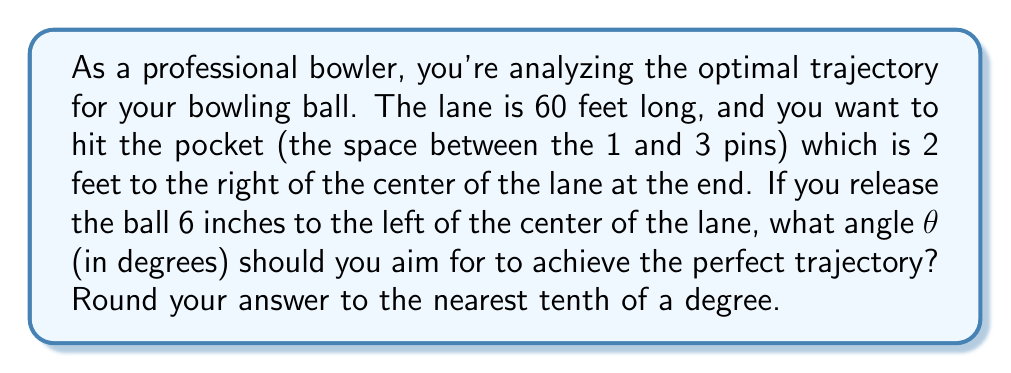Can you answer this question? Let's approach this step-by-step using trigonometry:

1) First, we need to visualize the problem. We have a right triangle where:
   - The length of the lane is the adjacent side (60 feet)
   - The horizontal distance the ball needs to travel is the opposite side

2) To find the opposite side, we need to add:
   - The distance from the pocket to the center (2 feet)
   - The distance from the release point to the center (0.5 feet)
   So, the total horizontal distance is 2.5 feet

3) Now we can use the tangent function to find the angle:

   $$\tan(\theta) = \frac{\text{opposite}}{\text{adjacent}} = \frac{2.5}{60}$$

4) To solve for θ, we use the inverse tangent (arctangent) function:

   $$\theta = \arctan(\frac{2.5}{60})$$

5) Using a calculator or computer:

   $$\theta = \arctan(0.041666...) \approx 2.3859...^\circ$$

6) Rounding to the nearest tenth of a degree:

   $$\theta \approx 2.4^\circ$$
Answer: $2.4^\circ$ 